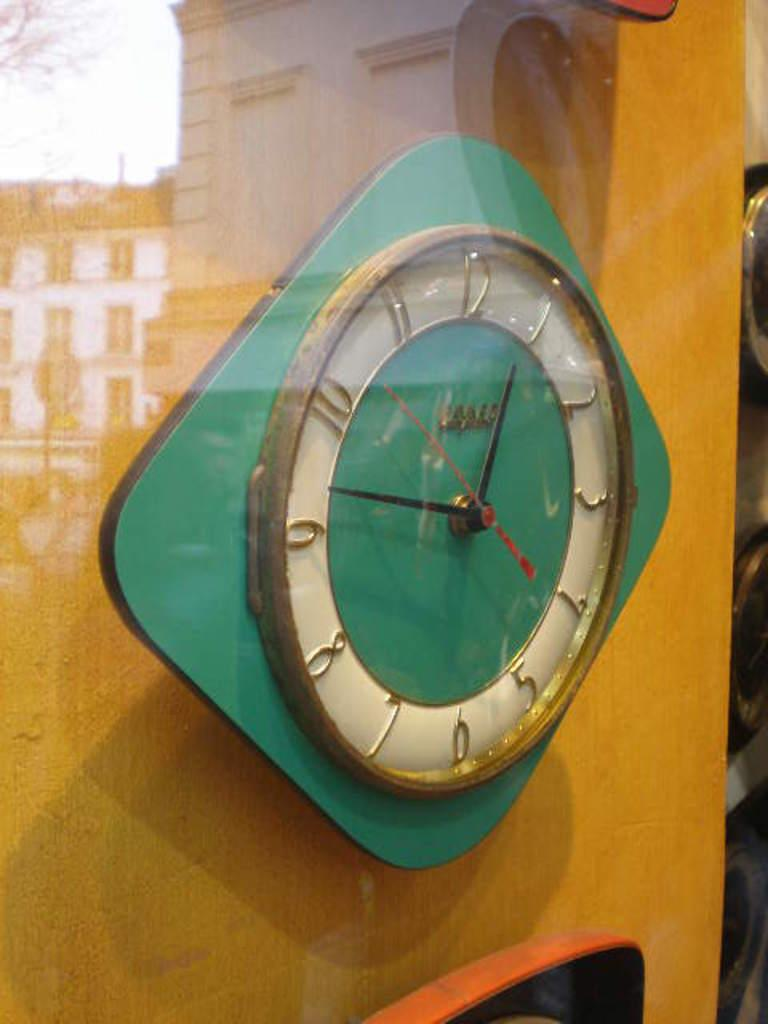<image>
Summarize the visual content of the image. Green clcok which has the hands on the numbers 1 and 9. 